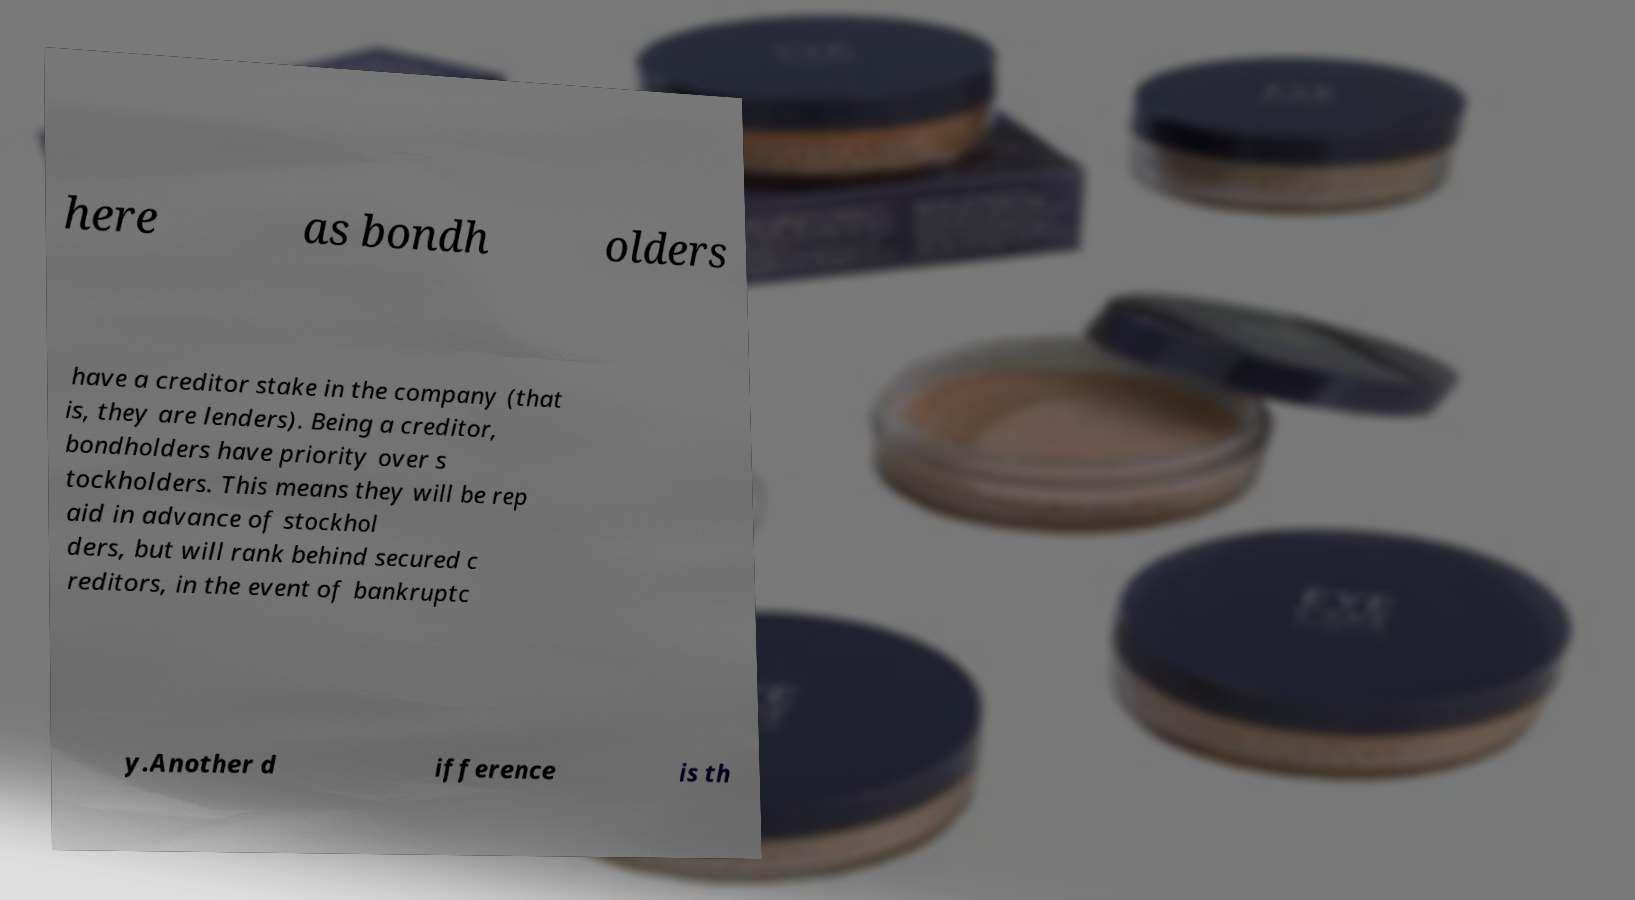Please identify and transcribe the text found in this image. here as bondh olders have a creditor stake in the company (that is, they are lenders). Being a creditor, bondholders have priority over s tockholders. This means they will be rep aid in advance of stockhol ders, but will rank behind secured c reditors, in the event of bankruptc y.Another d ifference is th 